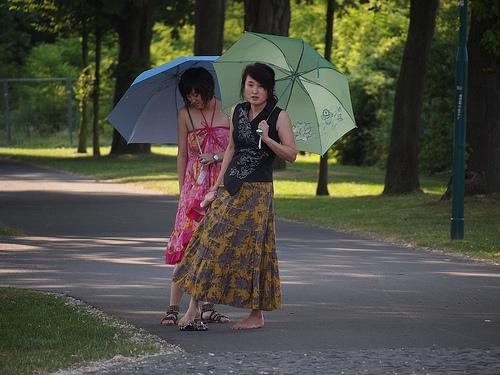Question: why are the woman holding umbrellas?
Choices:
A. To trade.
B. It's raining.
C. Weather.
D. To not get wet.
Answer with the letter. Answer: C Question: who is barefoot?
Choices:
A. Everyone.
B. First woman.
C. The kids.
D. A man.
Answer with the letter. Answer: B Question: how many people are pictured?
Choices:
A. 1.
B. 2.
C. 3.
D. 4.
Answer with the letter. Answer: B Question: when was the picture taken?
Choices:
A. Before dinner.
B. In the morning.
C. Morning.
D. Daytime.
Answer with the letter. Answer: C 